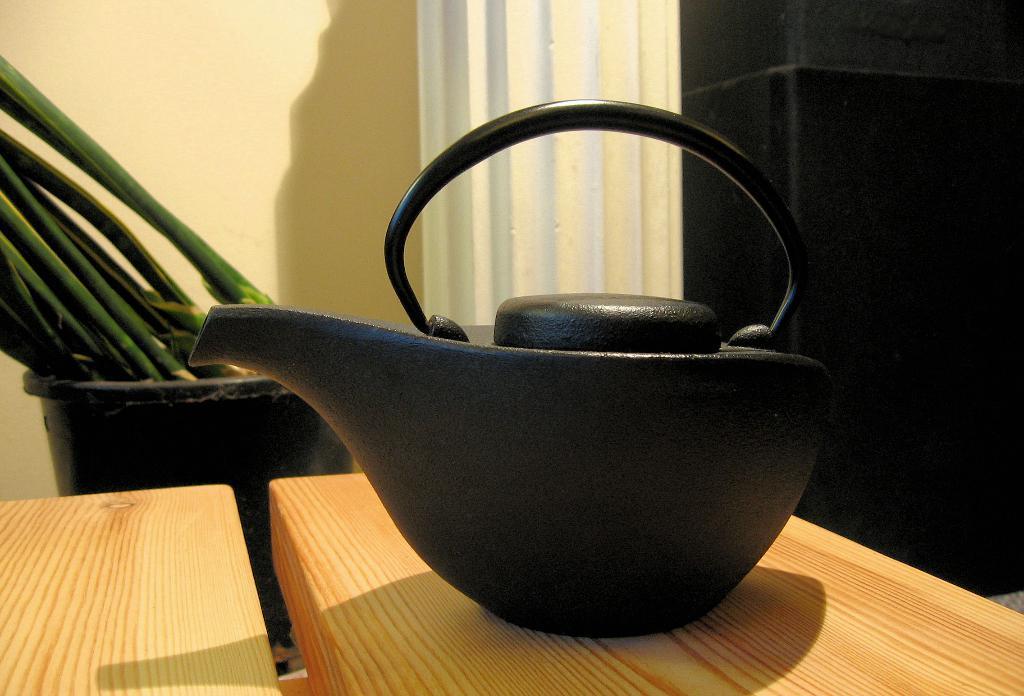Describe this image in one or two sentences. In this picture we can see a black object on the wooden table and behind the table there is a house plant and a wall. 